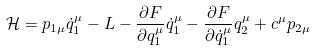<formula> <loc_0><loc_0><loc_500><loc_500>\mathcal { H } = p _ { 1 \mu } \dot { q } _ { 1 } ^ { \mu } - L - \frac { \partial F } { \partial q ^ { \mu } _ { 1 } } \dot { q } ^ { \mu } _ { 1 } - \frac { \partial F } { \partial \dot { q } ^ { \mu } _ { 1 } } q ^ { \mu } _ { 2 } + c ^ { \mu } p _ { 2 \mu }</formula> 